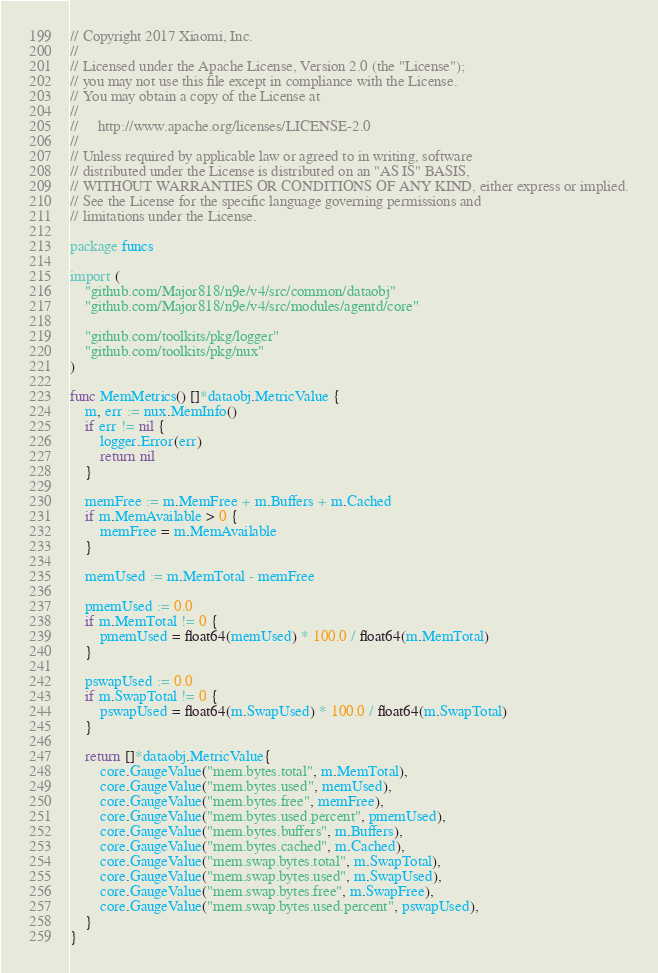Convert code to text. <code><loc_0><loc_0><loc_500><loc_500><_Go_>// Copyright 2017 Xiaomi, Inc.
//
// Licensed under the Apache License, Version 2.0 (the "License");
// you may not use this file except in compliance with the License.
// You may obtain a copy of the License at
//
//     http://www.apache.org/licenses/LICENSE-2.0
//
// Unless required by applicable law or agreed to in writing, software
// distributed under the License is distributed on an "AS IS" BASIS,
// WITHOUT WARRANTIES OR CONDITIONS OF ANY KIND, either express or implied.
// See the License for the specific language governing permissions and
// limitations under the License.

package funcs

import (
	"github.com/Major818/n9e/v4/src/common/dataobj"
	"github.com/Major818/n9e/v4/src/modules/agentd/core"

	"github.com/toolkits/pkg/logger"
	"github.com/toolkits/pkg/nux"
)

func MemMetrics() []*dataobj.MetricValue {
	m, err := nux.MemInfo()
	if err != nil {
		logger.Error(err)
		return nil
	}

	memFree := m.MemFree + m.Buffers + m.Cached
	if m.MemAvailable > 0 {
		memFree = m.MemAvailable
	}

	memUsed := m.MemTotal - memFree

	pmemUsed := 0.0
	if m.MemTotal != 0 {
		pmemUsed = float64(memUsed) * 100.0 / float64(m.MemTotal)
	}

	pswapUsed := 0.0
	if m.SwapTotal != 0 {
		pswapUsed = float64(m.SwapUsed) * 100.0 / float64(m.SwapTotal)
	}

	return []*dataobj.MetricValue{
		core.GaugeValue("mem.bytes.total", m.MemTotal),
		core.GaugeValue("mem.bytes.used", memUsed),
		core.GaugeValue("mem.bytes.free", memFree),
		core.GaugeValue("mem.bytes.used.percent", pmemUsed),
		core.GaugeValue("mem.bytes.buffers", m.Buffers),
		core.GaugeValue("mem.bytes.cached", m.Cached),
		core.GaugeValue("mem.swap.bytes.total", m.SwapTotal),
		core.GaugeValue("mem.swap.bytes.used", m.SwapUsed),
		core.GaugeValue("mem.swap.bytes.free", m.SwapFree),
		core.GaugeValue("mem.swap.bytes.used.percent", pswapUsed),
	}
}
</code> 